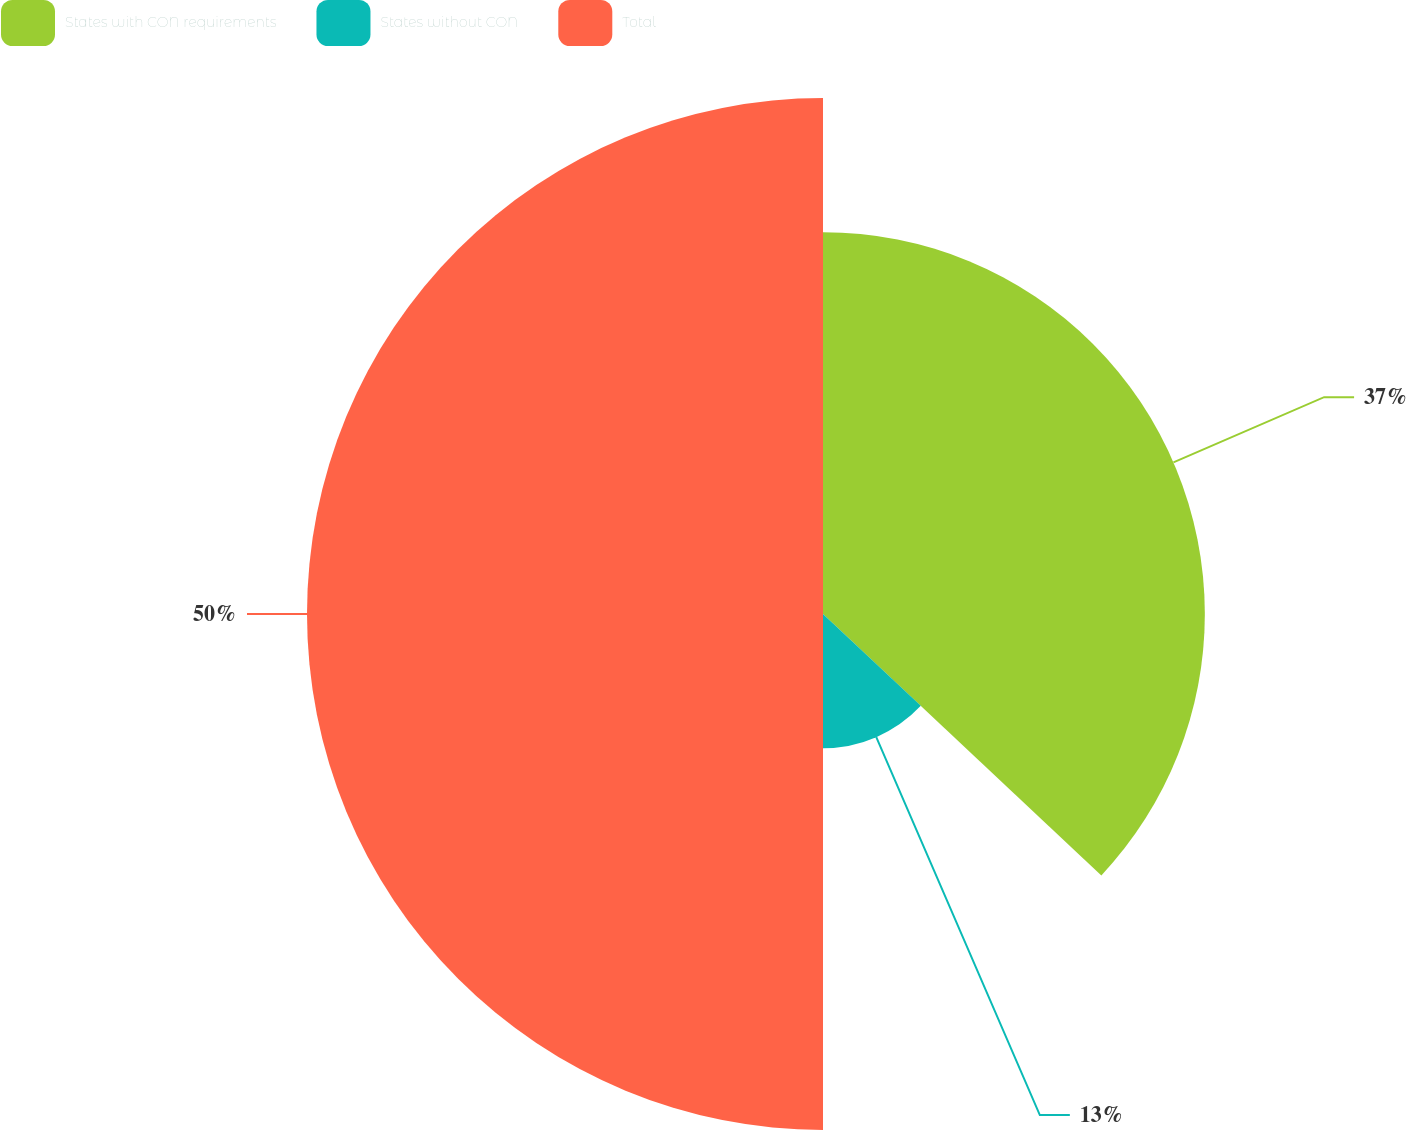<chart> <loc_0><loc_0><loc_500><loc_500><pie_chart><fcel>States with CON requirements<fcel>States without CON<fcel>Total<nl><fcel>37.0%<fcel>13.0%<fcel>50.0%<nl></chart> 